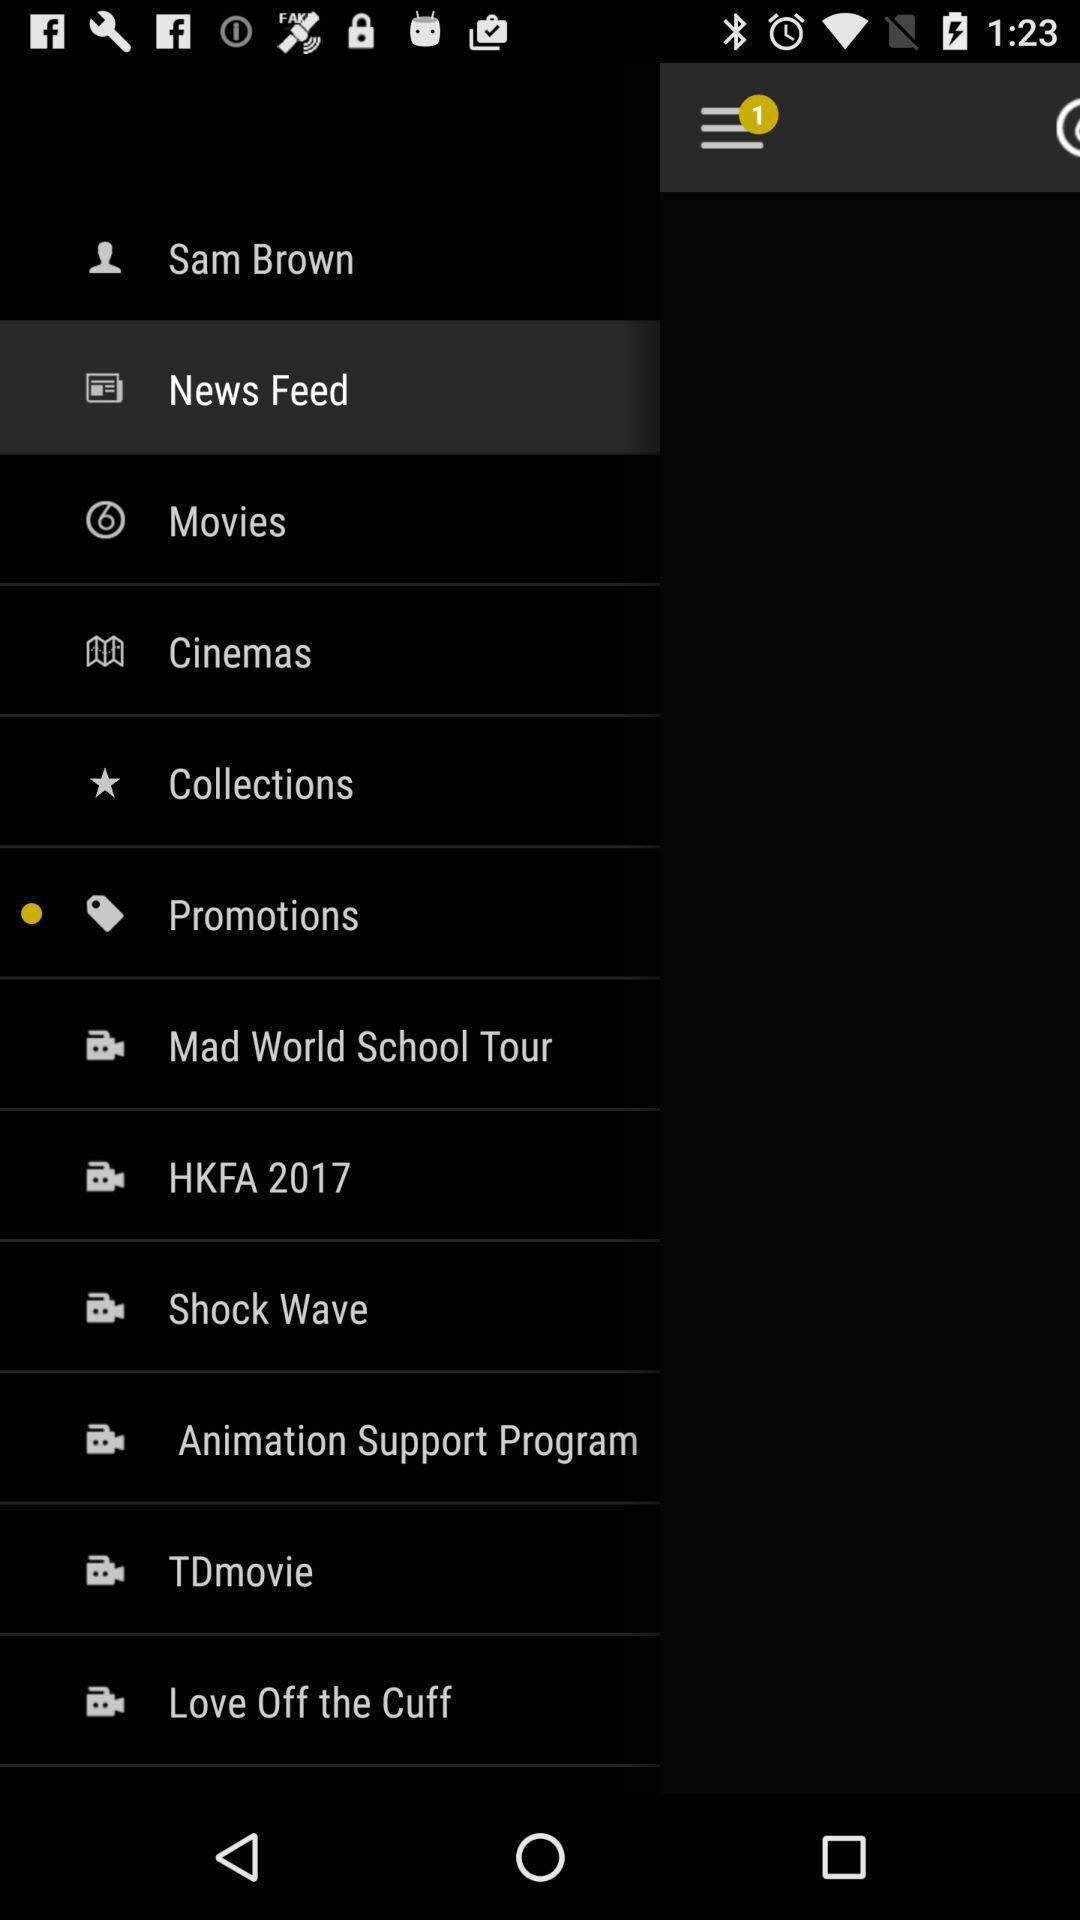What item is selected in the menu? The selected item in the menu is "News Feed". 